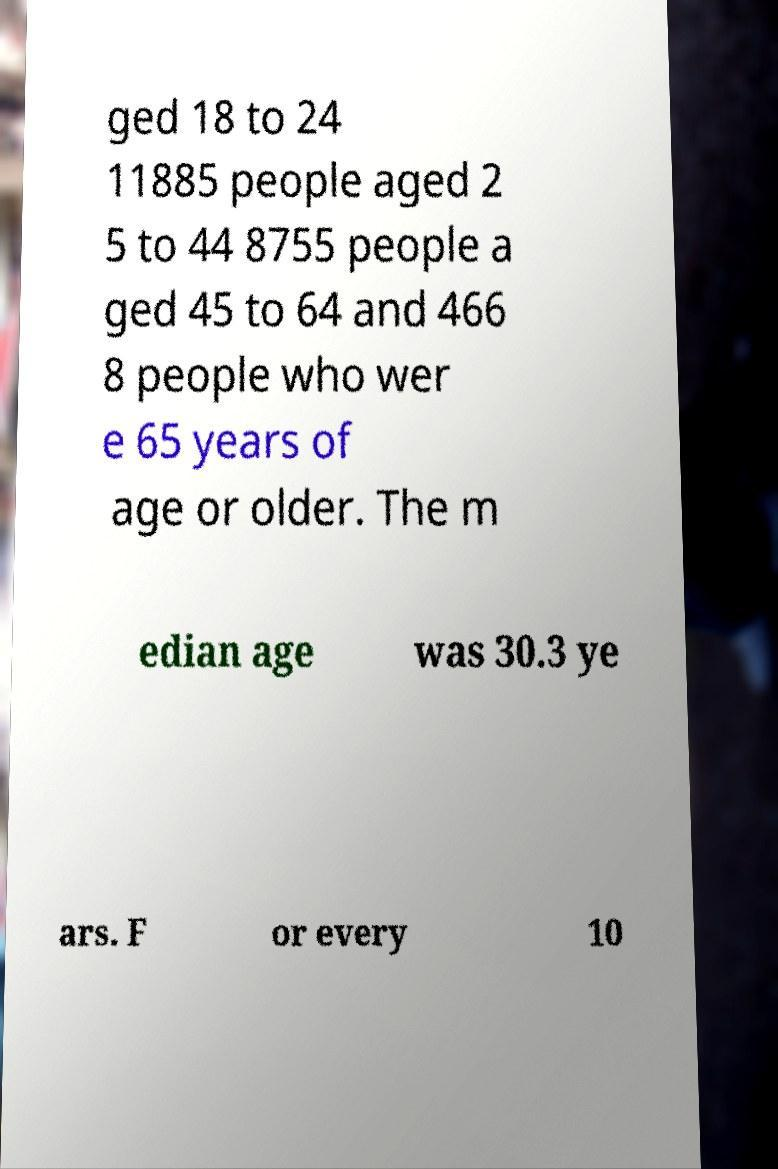What messages or text are displayed in this image? I need them in a readable, typed format. ged 18 to 24 11885 people aged 2 5 to 44 8755 people a ged 45 to 64 and 466 8 people who wer e 65 years of age or older. The m edian age was 30.3 ye ars. F or every 10 